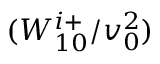Convert formula to latex. <formula><loc_0><loc_0><loc_500><loc_500>( W _ { 1 0 } ^ { i + } / v _ { 0 } ^ { 2 } )</formula> 